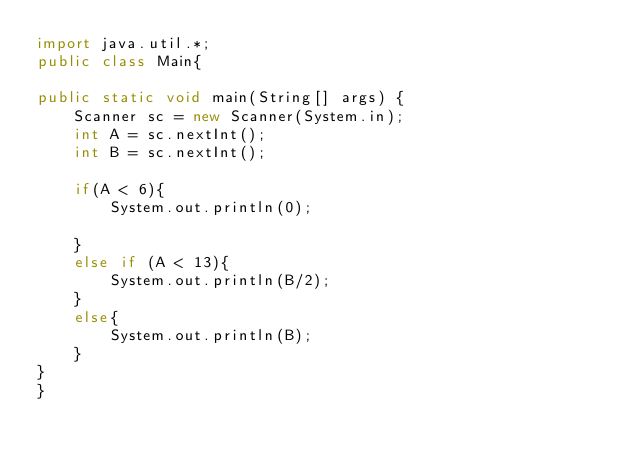Convert code to text. <code><loc_0><loc_0><loc_500><loc_500><_Java_>import java.util.*;
public class Main{

public static void main(String[] args) {
	Scanner sc = new Scanner(System.in);
	int A = sc.nextInt();
	int B = sc.nextInt();

	if(A < 6){
		System.out.println(0);
		
	}
	else if (A < 13){
		System.out.println(B/2);
	}
	else{
		System.out.println(B);
	}
}	
}</code> 